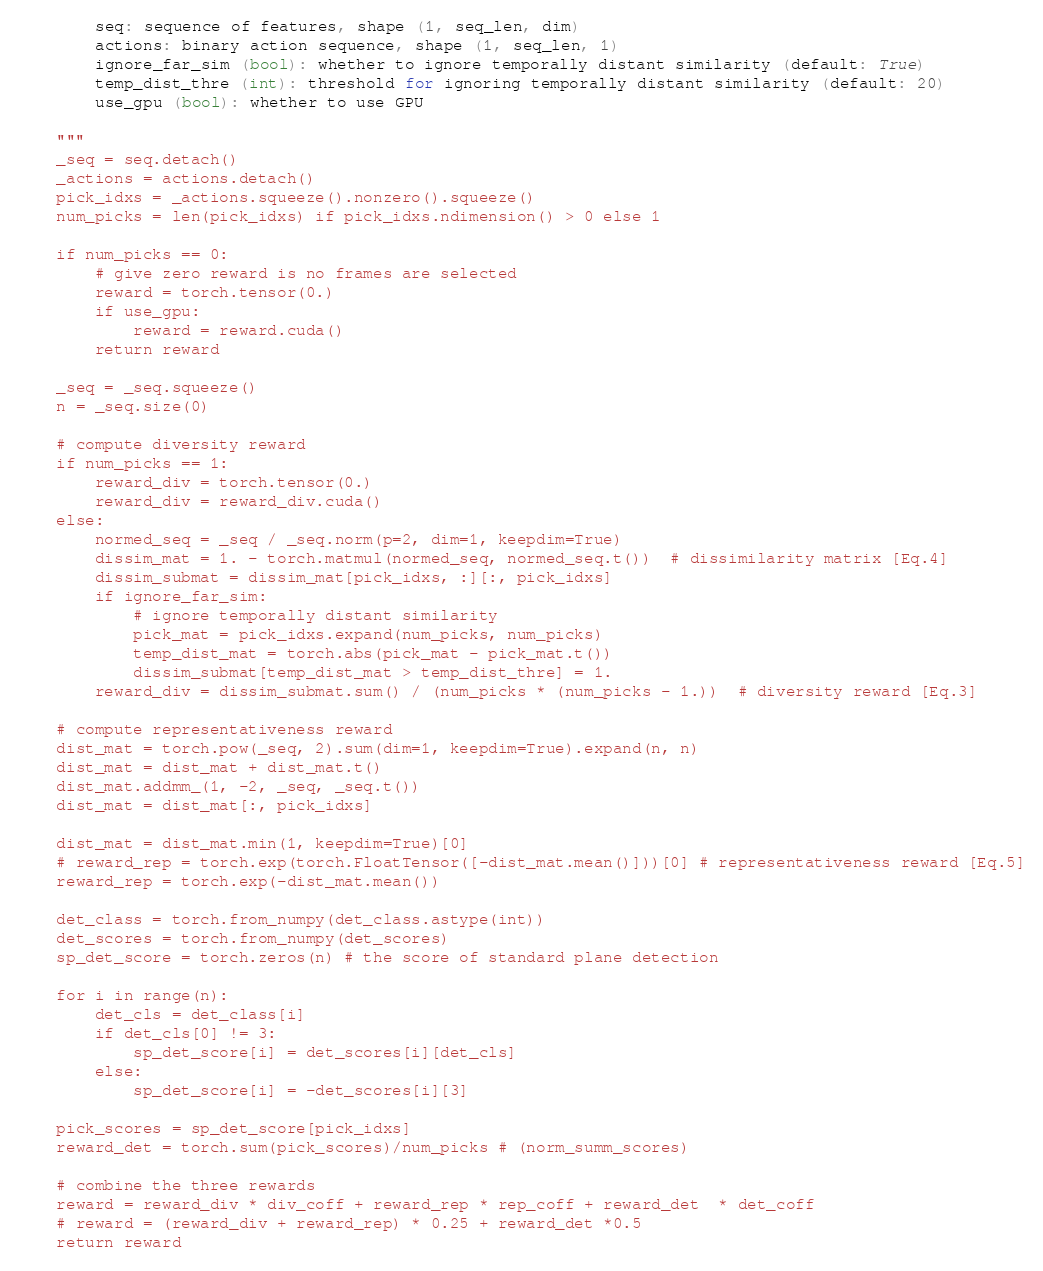Convert code to text. <code><loc_0><loc_0><loc_500><loc_500><_Python_>        seq: sequence of features, shape (1, seq_len, dim)
        actions: binary action sequence, shape (1, seq_len, 1)
        ignore_far_sim (bool): whether to ignore temporally distant similarity (default: True)
        temp_dist_thre (int): threshold for ignoring temporally distant similarity (default: 20)
        use_gpu (bool): whether to use GPU

    """
    _seq = seq.detach()
    _actions = actions.detach()
    pick_idxs = _actions.squeeze().nonzero().squeeze()
    num_picks = len(pick_idxs) if pick_idxs.ndimension() > 0 else 1

    if num_picks == 0:
        # give zero reward is no frames are selected
        reward = torch.tensor(0.)
        if use_gpu:
            reward = reward.cuda()
        return reward

    _seq = _seq.squeeze()
    n = _seq.size(0)

    # compute diversity reward
    if num_picks == 1:
        reward_div = torch.tensor(0.)
        reward_div = reward_div.cuda()
    else:
        normed_seq = _seq / _seq.norm(p=2, dim=1, keepdim=True)
        dissim_mat = 1. - torch.matmul(normed_seq, normed_seq.t())  # dissimilarity matrix [Eq.4]
        dissim_submat = dissim_mat[pick_idxs, :][:, pick_idxs]
        if ignore_far_sim:
            # ignore temporally distant similarity
            pick_mat = pick_idxs.expand(num_picks, num_picks)
            temp_dist_mat = torch.abs(pick_mat - pick_mat.t())
            dissim_submat[temp_dist_mat > temp_dist_thre] = 1.
        reward_div = dissim_submat.sum() / (num_picks * (num_picks - 1.))  # diversity reward [Eq.3]

    # compute representativeness reward
    dist_mat = torch.pow(_seq, 2).sum(dim=1, keepdim=True).expand(n, n)
    dist_mat = dist_mat + dist_mat.t()
    dist_mat.addmm_(1, -2, _seq, _seq.t())
    dist_mat = dist_mat[:, pick_idxs]

    dist_mat = dist_mat.min(1, keepdim=True)[0]
    # reward_rep = torch.exp(torch.FloatTensor([-dist_mat.mean()]))[0] # representativeness reward [Eq.5]
    reward_rep = torch.exp(-dist_mat.mean())

    det_class = torch.from_numpy(det_class.astype(int))
    det_scores = torch.from_numpy(det_scores)
    sp_det_score = torch.zeros(n) # the score of standard plane detection

    for i in range(n):
        det_cls = det_class[i]
        if det_cls[0] != 3:
            sp_det_score[i] = det_scores[i][det_cls]
        else:
            sp_det_score[i] = -det_scores[i][3]

    pick_scores = sp_det_score[pick_idxs]
    reward_det = torch.sum(pick_scores)/num_picks # (norm_summ_scores)

    # combine the three rewards
    reward = reward_div * div_coff + reward_rep * rep_coff + reward_det  * det_coff
    # reward = (reward_div + reward_rep) * 0.25 + reward_det *0.5
    return reward

</code> 